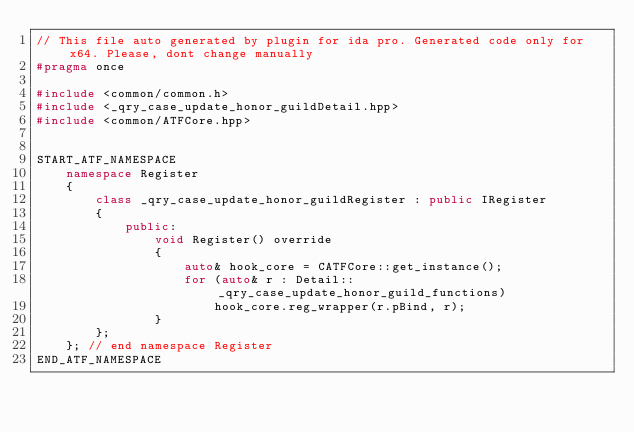<code> <loc_0><loc_0><loc_500><loc_500><_C++_>// This file auto generated by plugin for ida pro. Generated code only for x64. Please, dont change manually
#pragma once

#include <common/common.h>
#include <_qry_case_update_honor_guildDetail.hpp>
#include <common/ATFCore.hpp>


START_ATF_NAMESPACE
    namespace Register
    {
        class _qry_case_update_honor_guildRegister : public IRegister
        {
            public: 
                void Register() override
                {
                    auto& hook_core = CATFCore::get_instance();
                    for (auto& r : Detail::_qry_case_update_honor_guild_functions)
                        hook_core.reg_wrapper(r.pBind, r);
                }
        };
    }; // end namespace Register
END_ATF_NAMESPACE
</code> 